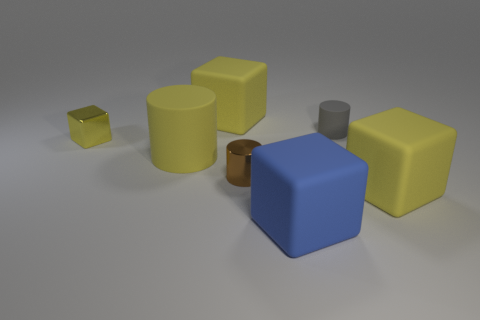Subtract all purple spheres. How many yellow blocks are left? 3 Add 1 big purple rubber things. How many objects exist? 8 Subtract all blocks. How many objects are left? 3 Add 2 big cubes. How many big cubes exist? 5 Subtract 3 yellow blocks. How many objects are left? 4 Subtract all brown cylinders. Subtract all small metal cylinders. How many objects are left? 5 Add 7 big yellow objects. How many big yellow objects are left? 10 